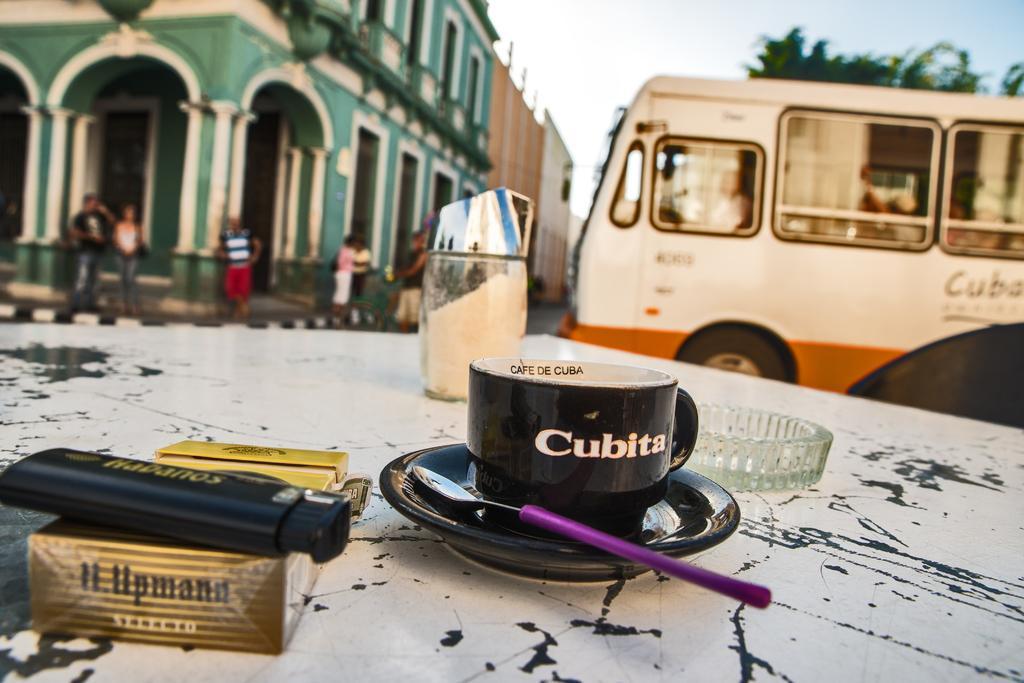Can you describe this image briefly? In this picture we can see a platform, on this platform we can see a cup, saucer, spoon and some objects and in the background we can see a building, people, vehicle, trees, sky. 